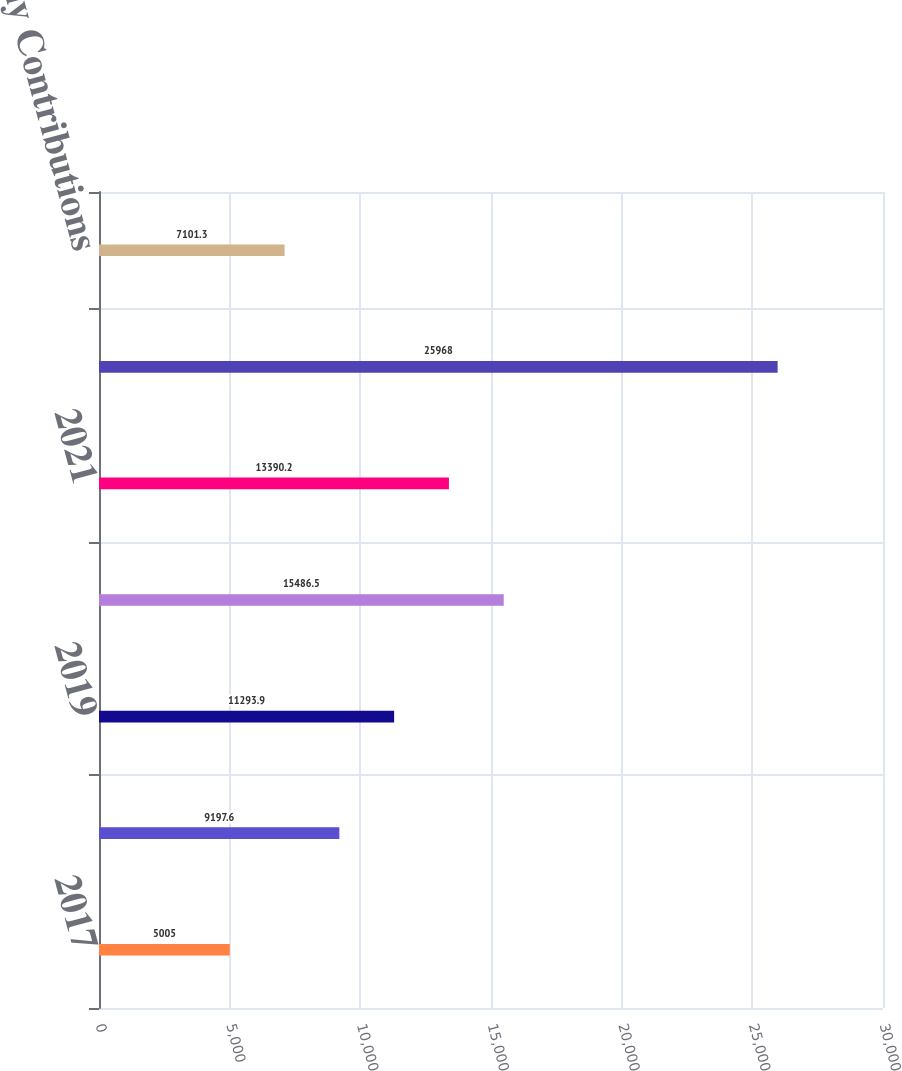Convert chart. <chart><loc_0><loc_0><loc_500><loc_500><bar_chart><fcel>2017<fcel>2018<fcel>2019<fcel>2020<fcel>2021<fcel>2022 - 2026<fcel>Required Company Contributions<nl><fcel>5005<fcel>9197.6<fcel>11293.9<fcel>15486.5<fcel>13390.2<fcel>25968<fcel>7101.3<nl></chart> 